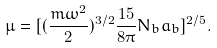<formula> <loc_0><loc_0><loc_500><loc_500>\mu = [ ( \frac { m \omega ^ { 2 } } { 2 } ) ^ { 3 / 2 } \frac { 1 5 } { 8 \pi } N _ { b } a _ { b } ] ^ { 2 / 5 } .</formula> 